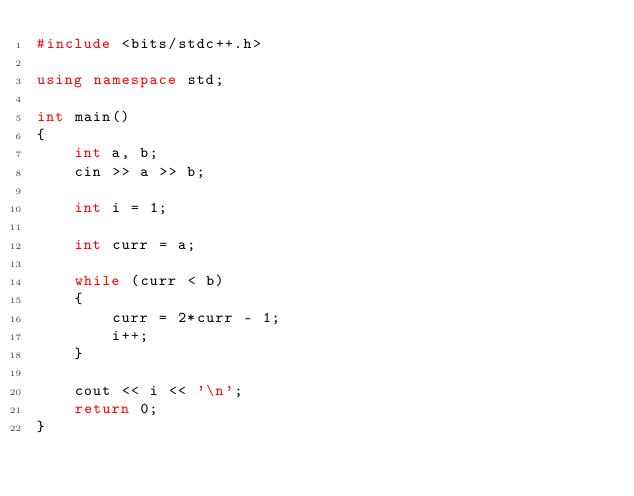Convert code to text. <code><loc_0><loc_0><loc_500><loc_500><_C++_>#include <bits/stdc++.h>

using namespace std;

int main()
{
    int a, b;
    cin >> a >> b;

    int i = 1;

    int curr = a;

    while (curr < b)
    {
        curr = 2*curr - 1;
        i++;
    }

    cout << i << '\n';
    return 0;
}
</code> 